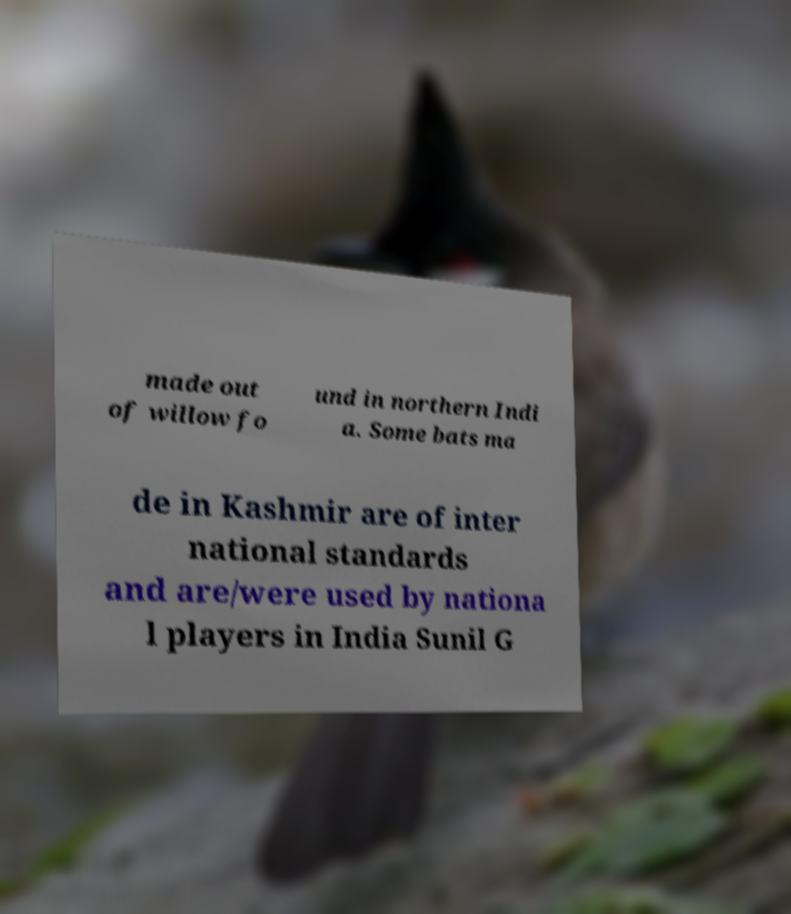There's text embedded in this image that I need extracted. Can you transcribe it verbatim? made out of willow fo und in northern Indi a. Some bats ma de in Kashmir are of inter national standards and are/were used by nationa l players in India Sunil G 